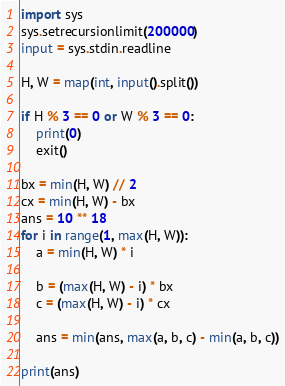Convert code to text. <code><loc_0><loc_0><loc_500><loc_500><_Python_>import sys
sys.setrecursionlimit(200000)
input = sys.stdin.readline

H, W = map(int, input().split())

if H % 3 == 0 or W % 3 == 0:
    print(0)
    exit()

bx = min(H, W) // 2
cx = min(H, W) - bx
ans = 10 ** 18
for i in range(1, max(H, W)):
    a = min(H, W) * i

    b = (max(H, W) - i) * bx
    c = (max(H, W) - i) * cx

    ans = min(ans, max(a, b, c) - min(a, b, c))

print(ans)</code> 